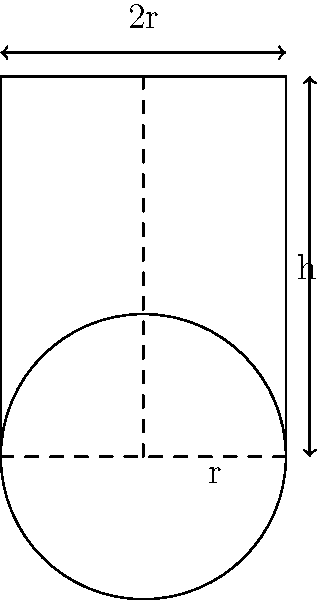An ancient cylindrical water storage tank has been discovered at an archaeological site. The tank has a diameter of 6 meters and a height of 8 meters. Calculate the volume of this tank in cubic meters, assuming it is a perfect cylinder. Round your answer to the nearest whole number. To calculate the volume of a cylinder, we use the formula:

$$V = \pi r^2 h$$

Where:
$V$ = volume
$r$ = radius
$h$ = height

Let's solve this step-by-step:

1) First, we need to find the radius. The diameter is 6 meters, so the radius is half of that:
   $$r = 6 \div 2 = 3 \text{ meters}$$

2) Now we have all the values:
   $r = 3 \text{ meters}$
   $h = 8 \text{ meters}$

3) Let's substitute these into our formula:
   $$V = \pi (3^2) (8)$$

4) Simplify:
   $$V = \pi (9) (8) = 72\pi$$

5) Calculate (using 3.14159 for $\pi$):
   $$V = 72 * 3.14159 = 226.19448 \text{ cubic meters}$$

6) Rounding to the nearest whole number:
   $$V \approx 226 \text{ cubic meters}$$
Answer: 226 cubic meters 